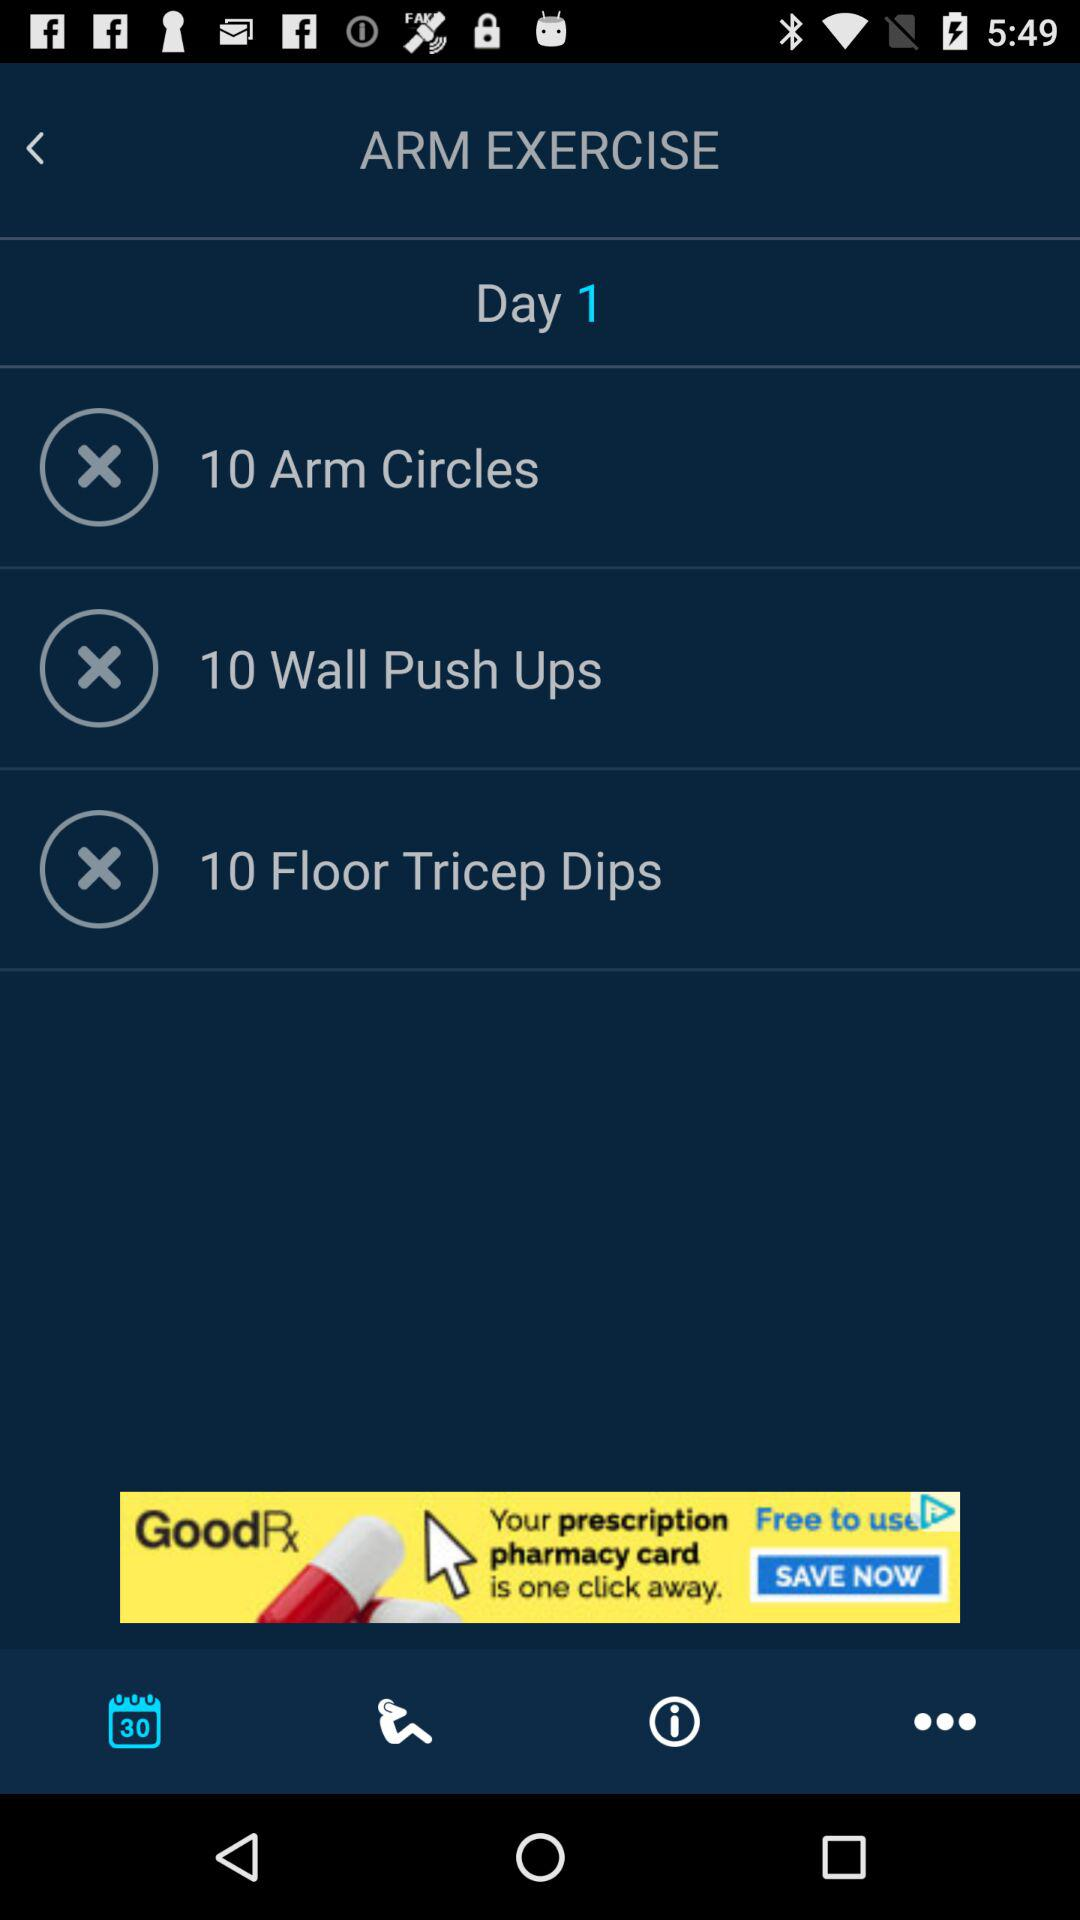What day of arm exercise is this? This is day 1 excercise. 